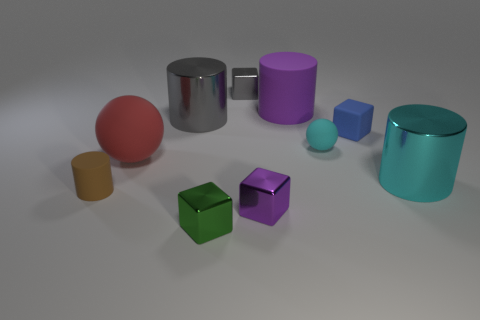Is the size of the cyan thing that is right of the rubber cube the same as the shiny cylinder that is on the left side of the big cyan object?
Your answer should be compact. Yes. There is a small metallic cube that is behind the cylinder that is on the left side of the big matte object left of the green metal object; what color is it?
Provide a short and direct response. Gray. Are there any brown objects of the same shape as the large red object?
Your answer should be compact. No. Are there an equal number of small objects that are left of the green metal thing and large purple rubber cylinders left of the large red rubber object?
Keep it short and to the point. No. Is the shape of the large purple object that is behind the large cyan cylinder the same as  the big gray thing?
Provide a short and direct response. Yes. Does the tiny gray object have the same shape as the large purple matte object?
Keep it short and to the point. No. How many shiny objects are either big red spheres or gray cylinders?
Your answer should be compact. 1. What is the material of the object that is the same color as the tiny sphere?
Provide a succinct answer. Metal. Is the red rubber object the same size as the green metal thing?
Provide a succinct answer. No. What number of things are green things or big cylinders that are on the left side of the big cyan metallic cylinder?
Offer a terse response. 3. 